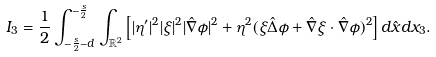Convert formula to latex. <formula><loc_0><loc_0><loc_500><loc_500>I _ { 3 } = \frac { 1 } { 2 } \int _ { - \frac { s } { 2 } - d } ^ { - \frac { s } { 2 } } \int _ { \mathbb { R } ^ { 2 } } \left [ | \eta ^ { \prime } | ^ { 2 } | \xi | ^ { 2 } | \hat { \nabla } \phi | ^ { 2 } + \eta ^ { 2 } ( \xi \hat { \Delta } \phi + \hat { \nabla } \xi \cdot \hat { \nabla } \phi ) ^ { 2 } \right ] d \hat { x } d x _ { 3 } .</formula> 